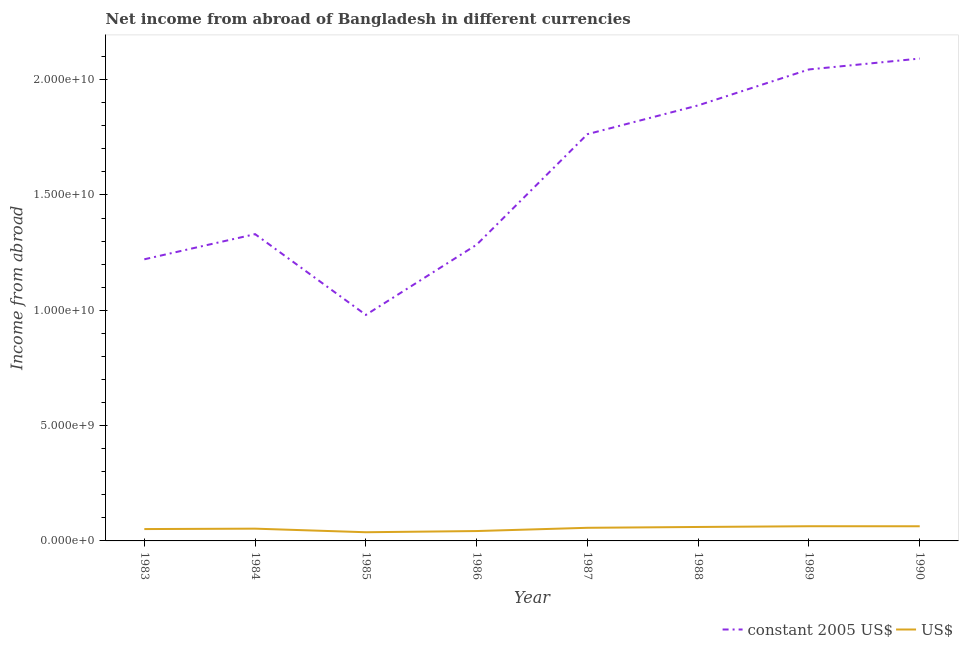Does the line corresponding to income from abroad in us$ intersect with the line corresponding to income from abroad in constant 2005 us$?
Keep it short and to the point. No. What is the income from abroad in constant 2005 us$ in 1988?
Your answer should be compact. 1.89e+1. Across all years, what is the maximum income from abroad in constant 2005 us$?
Your response must be concise. 2.09e+1. Across all years, what is the minimum income from abroad in constant 2005 us$?
Give a very brief answer. 9.80e+09. In which year was the income from abroad in constant 2005 us$ maximum?
Offer a very short reply. 1990. In which year was the income from abroad in us$ minimum?
Your response must be concise. 1985. What is the total income from abroad in constant 2005 us$ in the graph?
Your answer should be very brief. 1.26e+11. What is the difference between the income from abroad in us$ in 1985 and that in 1986?
Offer a very short reply. -5.12e+07. What is the difference between the income from abroad in us$ in 1989 and the income from abroad in constant 2005 us$ in 1984?
Keep it short and to the point. -1.27e+1. What is the average income from abroad in us$ per year?
Offer a terse response. 5.37e+08. In the year 1985, what is the difference between the income from abroad in constant 2005 us$ and income from abroad in us$?
Make the answer very short. 9.42e+09. What is the ratio of the income from abroad in constant 2005 us$ in 1986 to that in 1988?
Your answer should be compact. 0.68. Is the income from abroad in us$ in 1985 less than that in 1988?
Offer a very short reply. Yes. Is the difference between the income from abroad in constant 2005 us$ in 1983 and 1986 greater than the difference between the income from abroad in us$ in 1983 and 1986?
Offer a terse response. No. What is the difference between the highest and the second highest income from abroad in constant 2005 us$?
Your answer should be very brief. 4.72e+08. What is the difference between the highest and the lowest income from abroad in us$?
Provide a short and direct response. 2.60e+08. In how many years, is the income from abroad in constant 2005 us$ greater than the average income from abroad in constant 2005 us$ taken over all years?
Your response must be concise. 4. Is the sum of the income from abroad in us$ in 1987 and 1988 greater than the maximum income from abroad in constant 2005 us$ across all years?
Keep it short and to the point. No. Does the income from abroad in us$ monotonically increase over the years?
Your answer should be compact. No. How many lines are there?
Offer a terse response. 2. How many years are there in the graph?
Keep it short and to the point. 8. What is the difference between two consecutive major ticks on the Y-axis?
Your answer should be compact. 5.00e+09. Are the values on the major ticks of Y-axis written in scientific E-notation?
Keep it short and to the point. Yes. Does the graph contain any zero values?
Offer a terse response. No. Where does the legend appear in the graph?
Your answer should be compact. Bottom right. How many legend labels are there?
Give a very brief answer. 2. What is the title of the graph?
Your response must be concise. Net income from abroad of Bangladesh in different currencies. What is the label or title of the Y-axis?
Make the answer very short. Income from abroad. What is the Income from abroad of constant 2005 US$ in 1983?
Provide a succinct answer. 1.22e+1. What is the Income from abroad of US$ in 1983?
Offer a terse response. 5.14e+08. What is the Income from abroad of constant 2005 US$ in 1984?
Offer a very short reply. 1.33e+1. What is the Income from abroad of US$ in 1984?
Provide a succinct answer. 5.32e+08. What is the Income from abroad of constant 2005 US$ in 1985?
Make the answer very short. 9.80e+09. What is the Income from abroad of US$ in 1985?
Offer a very short reply. 3.77e+08. What is the Income from abroad of constant 2005 US$ in 1986?
Keep it short and to the point. 1.28e+1. What is the Income from abroad of US$ in 1986?
Keep it short and to the point. 4.28e+08. What is the Income from abroad of constant 2005 US$ in 1987?
Offer a very short reply. 1.76e+1. What is the Income from abroad of US$ in 1987?
Give a very brief answer. 5.69e+08. What is the Income from abroad in constant 2005 US$ in 1988?
Keep it short and to the point. 1.89e+1. What is the Income from abroad in US$ in 1988?
Offer a terse response. 6.05e+08. What is the Income from abroad in constant 2005 US$ in 1989?
Make the answer very short. 2.04e+1. What is the Income from abroad in US$ in 1989?
Offer a terse response. 6.37e+08. What is the Income from abroad of constant 2005 US$ in 1990?
Make the answer very short. 2.09e+1. What is the Income from abroad in US$ in 1990?
Ensure brevity in your answer.  6.36e+08. Across all years, what is the maximum Income from abroad of constant 2005 US$?
Keep it short and to the point. 2.09e+1. Across all years, what is the maximum Income from abroad of US$?
Provide a short and direct response. 6.37e+08. Across all years, what is the minimum Income from abroad of constant 2005 US$?
Give a very brief answer. 9.80e+09. Across all years, what is the minimum Income from abroad of US$?
Keep it short and to the point. 3.77e+08. What is the total Income from abroad of constant 2005 US$ in the graph?
Give a very brief answer. 1.26e+11. What is the total Income from abroad in US$ in the graph?
Give a very brief answer. 4.30e+09. What is the difference between the Income from abroad in constant 2005 US$ in 1983 and that in 1984?
Offer a very short reply. -1.09e+09. What is the difference between the Income from abroad in US$ in 1983 and that in 1984?
Keep it short and to the point. -1.81e+07. What is the difference between the Income from abroad in constant 2005 US$ in 1983 and that in 1985?
Ensure brevity in your answer.  2.41e+09. What is the difference between the Income from abroad of US$ in 1983 and that in 1985?
Keep it short and to the point. 1.37e+08. What is the difference between the Income from abroad in constant 2005 US$ in 1983 and that in 1986?
Your response must be concise. -6.33e+08. What is the difference between the Income from abroad of US$ in 1983 and that in 1986?
Make the answer very short. 8.58e+07. What is the difference between the Income from abroad in constant 2005 US$ in 1983 and that in 1987?
Ensure brevity in your answer.  -5.42e+09. What is the difference between the Income from abroad of US$ in 1983 and that in 1987?
Keep it short and to the point. -5.50e+07. What is the difference between the Income from abroad in constant 2005 US$ in 1983 and that in 1988?
Your response must be concise. -6.67e+09. What is the difference between the Income from abroad in US$ in 1983 and that in 1988?
Keep it short and to the point. -9.14e+07. What is the difference between the Income from abroad of constant 2005 US$ in 1983 and that in 1989?
Provide a short and direct response. -8.23e+09. What is the difference between the Income from abroad in US$ in 1983 and that in 1989?
Offer a terse response. -1.23e+08. What is the difference between the Income from abroad of constant 2005 US$ in 1983 and that in 1990?
Offer a terse response. -8.70e+09. What is the difference between the Income from abroad in US$ in 1983 and that in 1990?
Make the answer very short. -1.22e+08. What is the difference between the Income from abroad of constant 2005 US$ in 1984 and that in 1985?
Give a very brief answer. 3.50e+09. What is the difference between the Income from abroad of US$ in 1984 and that in 1985?
Offer a very short reply. 1.55e+08. What is the difference between the Income from abroad in constant 2005 US$ in 1984 and that in 1986?
Ensure brevity in your answer.  4.58e+08. What is the difference between the Income from abroad in US$ in 1984 and that in 1986?
Your answer should be very brief. 1.04e+08. What is the difference between the Income from abroad of constant 2005 US$ in 1984 and that in 1987?
Your answer should be compact. -4.33e+09. What is the difference between the Income from abroad in US$ in 1984 and that in 1987?
Provide a succinct answer. -3.68e+07. What is the difference between the Income from abroad of constant 2005 US$ in 1984 and that in 1988?
Provide a succinct answer. -5.58e+09. What is the difference between the Income from abroad in US$ in 1984 and that in 1988?
Ensure brevity in your answer.  -7.32e+07. What is the difference between the Income from abroad in constant 2005 US$ in 1984 and that in 1989?
Your answer should be very brief. -7.14e+09. What is the difference between the Income from abroad of US$ in 1984 and that in 1989?
Offer a terse response. -1.05e+08. What is the difference between the Income from abroad of constant 2005 US$ in 1984 and that in 1990?
Provide a succinct answer. -7.61e+09. What is the difference between the Income from abroad of US$ in 1984 and that in 1990?
Give a very brief answer. -1.04e+08. What is the difference between the Income from abroad in constant 2005 US$ in 1985 and that in 1986?
Offer a terse response. -3.04e+09. What is the difference between the Income from abroad in US$ in 1985 and that in 1986?
Give a very brief answer. -5.12e+07. What is the difference between the Income from abroad in constant 2005 US$ in 1985 and that in 1987?
Your response must be concise. -7.84e+09. What is the difference between the Income from abroad in US$ in 1985 and that in 1987?
Give a very brief answer. -1.92e+08. What is the difference between the Income from abroad of constant 2005 US$ in 1985 and that in 1988?
Make the answer very short. -9.08e+09. What is the difference between the Income from abroad in US$ in 1985 and that in 1988?
Make the answer very short. -2.28e+08. What is the difference between the Income from abroad of constant 2005 US$ in 1985 and that in 1989?
Ensure brevity in your answer.  -1.06e+1. What is the difference between the Income from abroad of US$ in 1985 and that in 1989?
Offer a very short reply. -2.60e+08. What is the difference between the Income from abroad of constant 2005 US$ in 1985 and that in 1990?
Keep it short and to the point. -1.11e+1. What is the difference between the Income from abroad in US$ in 1985 and that in 1990?
Give a very brief answer. -2.59e+08. What is the difference between the Income from abroad of constant 2005 US$ in 1986 and that in 1987?
Keep it short and to the point. -4.79e+09. What is the difference between the Income from abroad of US$ in 1986 and that in 1987?
Keep it short and to the point. -1.41e+08. What is the difference between the Income from abroad of constant 2005 US$ in 1986 and that in 1988?
Keep it short and to the point. -6.04e+09. What is the difference between the Income from abroad in US$ in 1986 and that in 1988?
Provide a short and direct response. -1.77e+08. What is the difference between the Income from abroad of constant 2005 US$ in 1986 and that in 1989?
Give a very brief answer. -7.60e+09. What is the difference between the Income from abroad in US$ in 1986 and that in 1989?
Give a very brief answer. -2.09e+08. What is the difference between the Income from abroad in constant 2005 US$ in 1986 and that in 1990?
Make the answer very short. -8.07e+09. What is the difference between the Income from abroad of US$ in 1986 and that in 1990?
Ensure brevity in your answer.  -2.08e+08. What is the difference between the Income from abroad of constant 2005 US$ in 1987 and that in 1988?
Give a very brief answer. -1.25e+09. What is the difference between the Income from abroad of US$ in 1987 and that in 1988?
Your answer should be compact. -3.64e+07. What is the difference between the Income from abroad of constant 2005 US$ in 1987 and that in 1989?
Offer a very short reply. -2.81e+09. What is the difference between the Income from abroad of US$ in 1987 and that in 1989?
Your answer should be very brief. -6.80e+07. What is the difference between the Income from abroad of constant 2005 US$ in 1987 and that in 1990?
Your answer should be compact. -3.28e+09. What is the difference between the Income from abroad in US$ in 1987 and that in 1990?
Provide a short and direct response. -6.68e+07. What is the difference between the Income from abroad in constant 2005 US$ in 1988 and that in 1989?
Make the answer very short. -1.56e+09. What is the difference between the Income from abroad of US$ in 1988 and that in 1989?
Ensure brevity in your answer.  -3.16e+07. What is the difference between the Income from abroad of constant 2005 US$ in 1988 and that in 1990?
Your answer should be very brief. -2.03e+09. What is the difference between the Income from abroad of US$ in 1988 and that in 1990?
Ensure brevity in your answer.  -3.04e+07. What is the difference between the Income from abroad of constant 2005 US$ in 1989 and that in 1990?
Provide a short and direct response. -4.72e+08. What is the difference between the Income from abroad in US$ in 1989 and that in 1990?
Ensure brevity in your answer.  1.14e+06. What is the difference between the Income from abroad of constant 2005 US$ in 1983 and the Income from abroad of US$ in 1984?
Provide a succinct answer. 1.17e+1. What is the difference between the Income from abroad in constant 2005 US$ in 1983 and the Income from abroad in US$ in 1985?
Keep it short and to the point. 1.18e+1. What is the difference between the Income from abroad of constant 2005 US$ in 1983 and the Income from abroad of US$ in 1986?
Your answer should be compact. 1.18e+1. What is the difference between the Income from abroad of constant 2005 US$ in 1983 and the Income from abroad of US$ in 1987?
Your response must be concise. 1.16e+1. What is the difference between the Income from abroad of constant 2005 US$ in 1983 and the Income from abroad of US$ in 1988?
Give a very brief answer. 1.16e+1. What is the difference between the Income from abroad of constant 2005 US$ in 1983 and the Income from abroad of US$ in 1989?
Your response must be concise. 1.16e+1. What is the difference between the Income from abroad of constant 2005 US$ in 1983 and the Income from abroad of US$ in 1990?
Give a very brief answer. 1.16e+1. What is the difference between the Income from abroad of constant 2005 US$ in 1984 and the Income from abroad of US$ in 1985?
Your response must be concise. 1.29e+1. What is the difference between the Income from abroad of constant 2005 US$ in 1984 and the Income from abroad of US$ in 1986?
Make the answer very short. 1.29e+1. What is the difference between the Income from abroad in constant 2005 US$ in 1984 and the Income from abroad in US$ in 1987?
Keep it short and to the point. 1.27e+1. What is the difference between the Income from abroad in constant 2005 US$ in 1984 and the Income from abroad in US$ in 1988?
Ensure brevity in your answer.  1.27e+1. What is the difference between the Income from abroad of constant 2005 US$ in 1984 and the Income from abroad of US$ in 1989?
Make the answer very short. 1.27e+1. What is the difference between the Income from abroad of constant 2005 US$ in 1984 and the Income from abroad of US$ in 1990?
Offer a very short reply. 1.27e+1. What is the difference between the Income from abroad in constant 2005 US$ in 1985 and the Income from abroad in US$ in 1986?
Provide a short and direct response. 9.37e+09. What is the difference between the Income from abroad of constant 2005 US$ in 1985 and the Income from abroad of US$ in 1987?
Your response must be concise. 9.23e+09. What is the difference between the Income from abroad of constant 2005 US$ in 1985 and the Income from abroad of US$ in 1988?
Provide a short and direct response. 9.19e+09. What is the difference between the Income from abroad in constant 2005 US$ in 1985 and the Income from abroad in US$ in 1989?
Provide a succinct answer. 9.16e+09. What is the difference between the Income from abroad of constant 2005 US$ in 1985 and the Income from abroad of US$ in 1990?
Provide a succinct answer. 9.16e+09. What is the difference between the Income from abroad of constant 2005 US$ in 1986 and the Income from abroad of US$ in 1987?
Make the answer very short. 1.23e+1. What is the difference between the Income from abroad in constant 2005 US$ in 1986 and the Income from abroad in US$ in 1988?
Your answer should be compact. 1.22e+1. What is the difference between the Income from abroad of constant 2005 US$ in 1986 and the Income from abroad of US$ in 1989?
Make the answer very short. 1.22e+1. What is the difference between the Income from abroad of constant 2005 US$ in 1986 and the Income from abroad of US$ in 1990?
Keep it short and to the point. 1.22e+1. What is the difference between the Income from abroad of constant 2005 US$ in 1987 and the Income from abroad of US$ in 1988?
Make the answer very short. 1.70e+1. What is the difference between the Income from abroad of constant 2005 US$ in 1987 and the Income from abroad of US$ in 1989?
Provide a succinct answer. 1.70e+1. What is the difference between the Income from abroad of constant 2005 US$ in 1987 and the Income from abroad of US$ in 1990?
Offer a very short reply. 1.70e+1. What is the difference between the Income from abroad of constant 2005 US$ in 1988 and the Income from abroad of US$ in 1989?
Your answer should be compact. 1.82e+1. What is the difference between the Income from abroad in constant 2005 US$ in 1988 and the Income from abroad in US$ in 1990?
Provide a succinct answer. 1.82e+1. What is the difference between the Income from abroad of constant 2005 US$ in 1989 and the Income from abroad of US$ in 1990?
Ensure brevity in your answer.  1.98e+1. What is the average Income from abroad of constant 2005 US$ per year?
Ensure brevity in your answer.  1.58e+1. What is the average Income from abroad in US$ per year?
Provide a short and direct response. 5.37e+08. In the year 1983, what is the difference between the Income from abroad of constant 2005 US$ and Income from abroad of US$?
Your response must be concise. 1.17e+1. In the year 1984, what is the difference between the Income from abroad of constant 2005 US$ and Income from abroad of US$?
Keep it short and to the point. 1.28e+1. In the year 1985, what is the difference between the Income from abroad of constant 2005 US$ and Income from abroad of US$?
Ensure brevity in your answer.  9.42e+09. In the year 1986, what is the difference between the Income from abroad in constant 2005 US$ and Income from abroad in US$?
Your answer should be very brief. 1.24e+1. In the year 1987, what is the difference between the Income from abroad of constant 2005 US$ and Income from abroad of US$?
Provide a succinct answer. 1.71e+1. In the year 1988, what is the difference between the Income from abroad in constant 2005 US$ and Income from abroad in US$?
Provide a short and direct response. 1.83e+1. In the year 1989, what is the difference between the Income from abroad of constant 2005 US$ and Income from abroad of US$?
Keep it short and to the point. 1.98e+1. In the year 1990, what is the difference between the Income from abroad in constant 2005 US$ and Income from abroad in US$?
Provide a short and direct response. 2.03e+1. What is the ratio of the Income from abroad in constant 2005 US$ in 1983 to that in 1984?
Offer a terse response. 0.92. What is the ratio of the Income from abroad of US$ in 1983 to that in 1984?
Make the answer very short. 0.97. What is the ratio of the Income from abroad in constant 2005 US$ in 1983 to that in 1985?
Your answer should be very brief. 1.25. What is the ratio of the Income from abroad of US$ in 1983 to that in 1985?
Make the answer very short. 1.36. What is the ratio of the Income from abroad in constant 2005 US$ in 1983 to that in 1986?
Keep it short and to the point. 0.95. What is the ratio of the Income from abroad in US$ in 1983 to that in 1986?
Your response must be concise. 1.2. What is the ratio of the Income from abroad in constant 2005 US$ in 1983 to that in 1987?
Offer a very short reply. 0.69. What is the ratio of the Income from abroad in US$ in 1983 to that in 1987?
Keep it short and to the point. 0.9. What is the ratio of the Income from abroad in constant 2005 US$ in 1983 to that in 1988?
Offer a very short reply. 0.65. What is the ratio of the Income from abroad of US$ in 1983 to that in 1988?
Offer a very short reply. 0.85. What is the ratio of the Income from abroad in constant 2005 US$ in 1983 to that in 1989?
Your response must be concise. 0.6. What is the ratio of the Income from abroad in US$ in 1983 to that in 1989?
Your answer should be very brief. 0.81. What is the ratio of the Income from abroad of constant 2005 US$ in 1983 to that in 1990?
Your answer should be very brief. 0.58. What is the ratio of the Income from abroad of US$ in 1983 to that in 1990?
Ensure brevity in your answer.  0.81. What is the ratio of the Income from abroad in constant 2005 US$ in 1984 to that in 1985?
Make the answer very short. 1.36. What is the ratio of the Income from abroad in US$ in 1984 to that in 1985?
Your response must be concise. 1.41. What is the ratio of the Income from abroad in constant 2005 US$ in 1984 to that in 1986?
Provide a short and direct response. 1.04. What is the ratio of the Income from abroad in US$ in 1984 to that in 1986?
Your answer should be compact. 1.24. What is the ratio of the Income from abroad of constant 2005 US$ in 1984 to that in 1987?
Provide a short and direct response. 0.75. What is the ratio of the Income from abroad of US$ in 1984 to that in 1987?
Your answer should be very brief. 0.94. What is the ratio of the Income from abroad in constant 2005 US$ in 1984 to that in 1988?
Offer a very short reply. 0.7. What is the ratio of the Income from abroad of US$ in 1984 to that in 1988?
Your answer should be very brief. 0.88. What is the ratio of the Income from abroad of constant 2005 US$ in 1984 to that in 1989?
Keep it short and to the point. 0.65. What is the ratio of the Income from abroad in US$ in 1984 to that in 1989?
Your answer should be very brief. 0.84. What is the ratio of the Income from abroad of constant 2005 US$ in 1984 to that in 1990?
Keep it short and to the point. 0.64. What is the ratio of the Income from abroad of US$ in 1984 to that in 1990?
Ensure brevity in your answer.  0.84. What is the ratio of the Income from abroad of constant 2005 US$ in 1985 to that in 1986?
Offer a very short reply. 0.76. What is the ratio of the Income from abroad of US$ in 1985 to that in 1986?
Give a very brief answer. 0.88. What is the ratio of the Income from abroad in constant 2005 US$ in 1985 to that in 1987?
Keep it short and to the point. 0.56. What is the ratio of the Income from abroad in US$ in 1985 to that in 1987?
Ensure brevity in your answer.  0.66. What is the ratio of the Income from abroad of constant 2005 US$ in 1985 to that in 1988?
Give a very brief answer. 0.52. What is the ratio of the Income from abroad in US$ in 1985 to that in 1988?
Provide a succinct answer. 0.62. What is the ratio of the Income from abroad in constant 2005 US$ in 1985 to that in 1989?
Provide a succinct answer. 0.48. What is the ratio of the Income from abroad in US$ in 1985 to that in 1989?
Your answer should be very brief. 0.59. What is the ratio of the Income from abroad of constant 2005 US$ in 1985 to that in 1990?
Keep it short and to the point. 0.47. What is the ratio of the Income from abroad in US$ in 1985 to that in 1990?
Give a very brief answer. 0.59. What is the ratio of the Income from abroad in constant 2005 US$ in 1986 to that in 1987?
Give a very brief answer. 0.73. What is the ratio of the Income from abroad in US$ in 1986 to that in 1987?
Your answer should be compact. 0.75. What is the ratio of the Income from abroad in constant 2005 US$ in 1986 to that in 1988?
Offer a very short reply. 0.68. What is the ratio of the Income from abroad of US$ in 1986 to that in 1988?
Your response must be concise. 0.71. What is the ratio of the Income from abroad in constant 2005 US$ in 1986 to that in 1989?
Provide a short and direct response. 0.63. What is the ratio of the Income from abroad of US$ in 1986 to that in 1989?
Your answer should be very brief. 0.67. What is the ratio of the Income from abroad of constant 2005 US$ in 1986 to that in 1990?
Provide a succinct answer. 0.61. What is the ratio of the Income from abroad of US$ in 1986 to that in 1990?
Give a very brief answer. 0.67. What is the ratio of the Income from abroad in constant 2005 US$ in 1987 to that in 1988?
Provide a succinct answer. 0.93. What is the ratio of the Income from abroad of US$ in 1987 to that in 1988?
Give a very brief answer. 0.94. What is the ratio of the Income from abroad of constant 2005 US$ in 1987 to that in 1989?
Make the answer very short. 0.86. What is the ratio of the Income from abroad of US$ in 1987 to that in 1989?
Ensure brevity in your answer.  0.89. What is the ratio of the Income from abroad in constant 2005 US$ in 1987 to that in 1990?
Your answer should be compact. 0.84. What is the ratio of the Income from abroad of US$ in 1987 to that in 1990?
Make the answer very short. 0.89. What is the ratio of the Income from abroad in constant 2005 US$ in 1988 to that in 1989?
Give a very brief answer. 0.92. What is the ratio of the Income from abroad of US$ in 1988 to that in 1989?
Give a very brief answer. 0.95. What is the ratio of the Income from abroad of constant 2005 US$ in 1988 to that in 1990?
Offer a terse response. 0.9. What is the ratio of the Income from abroad in US$ in 1988 to that in 1990?
Ensure brevity in your answer.  0.95. What is the ratio of the Income from abroad of constant 2005 US$ in 1989 to that in 1990?
Offer a terse response. 0.98. What is the difference between the highest and the second highest Income from abroad of constant 2005 US$?
Your response must be concise. 4.72e+08. What is the difference between the highest and the second highest Income from abroad of US$?
Provide a short and direct response. 1.14e+06. What is the difference between the highest and the lowest Income from abroad of constant 2005 US$?
Your answer should be compact. 1.11e+1. What is the difference between the highest and the lowest Income from abroad of US$?
Provide a succinct answer. 2.60e+08. 